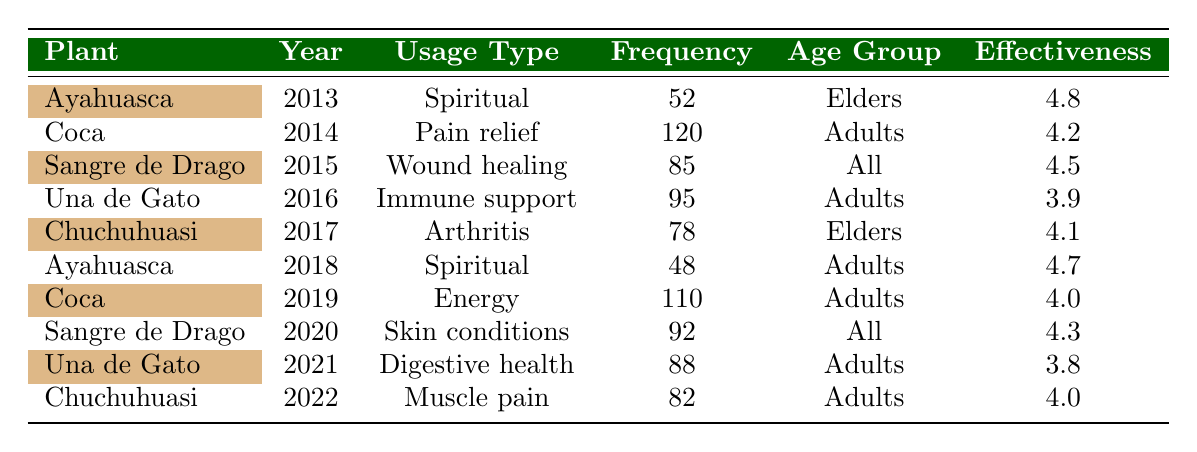What was the frequency of Ayahuasca usage in 2013? In the table, I can see that Ayahuasca was used 52 times in the year 2013, as it is listed directly in the corresponding row.
Answer: 52 Which plant had the highest frequency of usage in a single year? I look for the highest frequency value in the Frequency column across all years. The Coca plant in 2014 had a frequency of 120, which is the highest among all entries in the table.
Answer: Coca in 2014 What is the average effectiveness rating for plants used by Adults? I need to identify all the plants used by Adults and their effectiveness ratings, which are Una de Gato (3.9 in 2016, 3.8 in 2021), Chuchuhuasi (4.0 in 2022), Coca (4.2 in 2014, 4.0 in 2019), and Ayahuasca (4.7 in 2018). The total effectiveness ratings are 3.9 + 3.8 + 4.0 + 4.2 + 4.7 = 20.6, and since there are 5 ratings, the average is 20.6/5 = 4.12.
Answer: 4.12 Did the frequency of Sangre de Drago usage increase or decrease from 2015 to 2020? I compare the frequency for Sangre de Drago in 2015, which is 85, to that in 2020, which is 92. Since 92 is greater than 85, it shows an increase in usage from 2015 to 2020.
Answer: Increase Was Chuchuhuasi used for the same purpose each year it was reported? Looking at the table, I see that Chuchuhuasi was used for Arthritis in 2017 and for Muscle pain in 2022. Since the usage types are different across the years it was reported, the answer is no.
Answer: No What was the most effective plant overall? I examine the Effectiveness ratings for each plant across the years. The most effective plant is Ayahuasca in 2013 with a rating of 4.8, which is higher than any other plant's rating.
Answer: Ayahuasca in 2013 How many different usage types are represented for Una de Gato in the table? By checking the entries for Una de Gato, I see it appears twice in the table, for Immune support in 2016 and Digestive health in 2021. Thus, there are two distinct usage types for Una de Gato.
Answer: 2 What is the total frequency of Coca usage in the years reported? I add together the frequencies for Coca in the years listed. In 2014, the frequency is 120, and in 2019, the frequency is 110. So, 120 + 110 = 230 total uses of Coca across these two years.
Answer: 230 